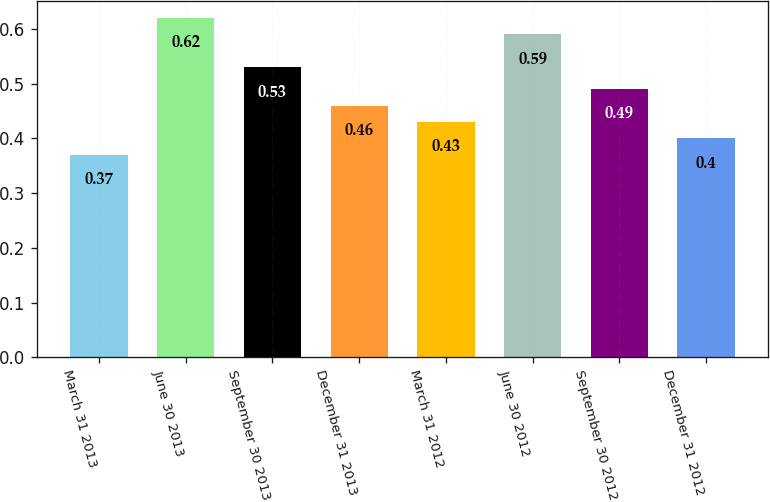Convert chart. <chart><loc_0><loc_0><loc_500><loc_500><bar_chart><fcel>March 31 2013<fcel>June 30 2013<fcel>September 30 2013<fcel>December 31 2013<fcel>March 31 2012<fcel>June 30 2012<fcel>September 30 2012<fcel>December 31 2012<nl><fcel>0.37<fcel>0.62<fcel>0.53<fcel>0.46<fcel>0.43<fcel>0.59<fcel>0.49<fcel>0.4<nl></chart> 